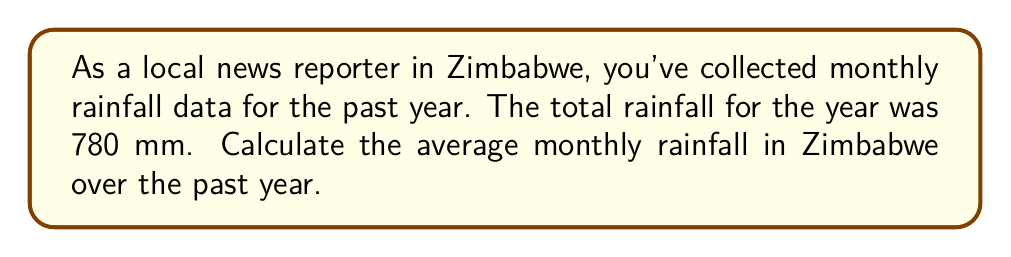Could you help me with this problem? To calculate the average monthly rainfall, we need to follow these steps:

1. Identify the given information:
   - Total annual rainfall: 780 mm
   - Number of months in a year: 12

2. Use the formula for calculating the average:
   $$ \text{Average} = \frac{\text{Sum of all values}}{\text{Number of values}} $$

3. In this case, we have:
   $$ \text{Average monthly rainfall} = \frac{\text{Total annual rainfall}}{\text{Number of months}} $$

4. Substitute the values:
   $$ \text{Average monthly rainfall} = \frac{780 \text{ mm}}{12} $$

5. Perform the division:
   $$ \text{Average monthly rainfall} = 65 \text{ mm} $$

Therefore, the average monthly rainfall in Zimbabwe over the past year is 65 mm.
Answer: 65 mm 